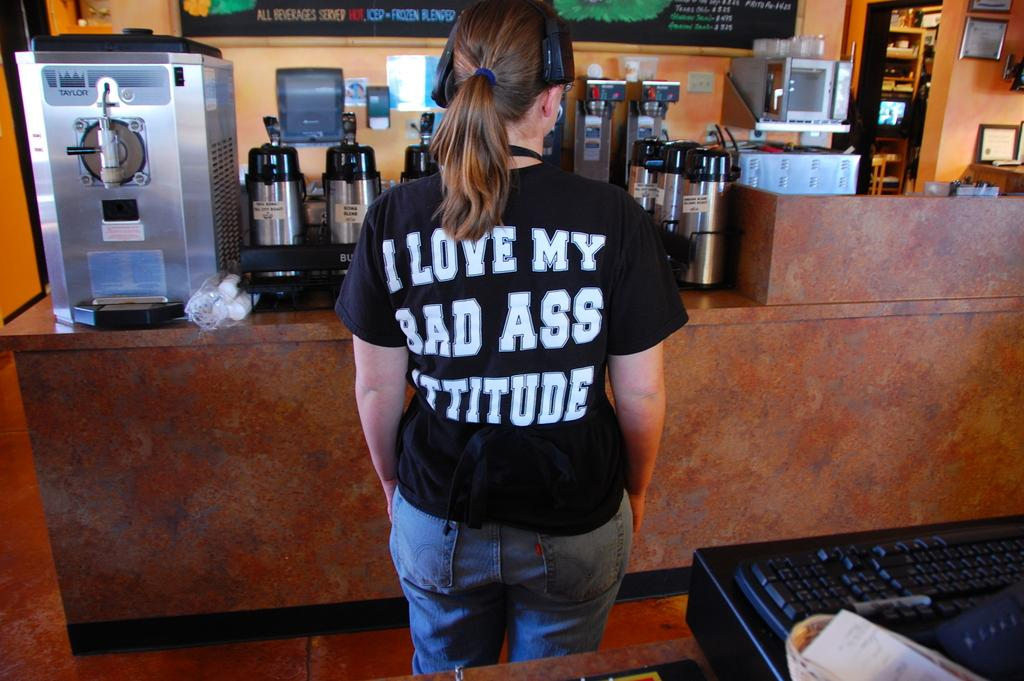<image>
Give a short and clear explanation of the subsequent image. a shirt that says I love my bad ass attitude on it 